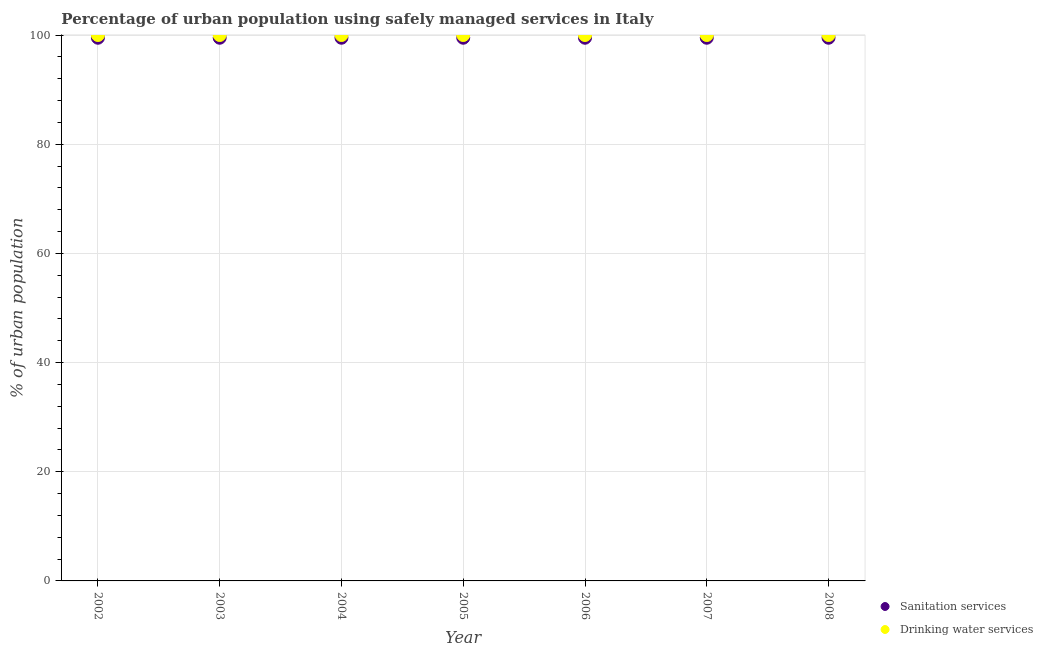How many different coloured dotlines are there?
Ensure brevity in your answer.  2. Is the number of dotlines equal to the number of legend labels?
Give a very brief answer. Yes. What is the percentage of urban population who used sanitation services in 2006?
Offer a terse response. 99.5. Across all years, what is the maximum percentage of urban population who used sanitation services?
Make the answer very short. 99.5. Across all years, what is the minimum percentage of urban population who used drinking water services?
Offer a very short reply. 100. In which year was the percentage of urban population who used sanitation services maximum?
Your answer should be compact. 2002. In which year was the percentage of urban population who used drinking water services minimum?
Provide a short and direct response. 2002. What is the total percentage of urban population who used sanitation services in the graph?
Provide a short and direct response. 696.5. What is the difference between the percentage of urban population who used sanitation services in 2002 and the percentage of urban population who used drinking water services in 2004?
Make the answer very short. -0.5. What is the average percentage of urban population who used drinking water services per year?
Your response must be concise. 100. In how many years, is the percentage of urban population who used drinking water services greater than 12 %?
Make the answer very short. 7. Is the percentage of urban population who used drinking water services in 2005 less than that in 2007?
Your response must be concise. No. Is the difference between the percentage of urban population who used sanitation services in 2005 and 2007 greater than the difference between the percentage of urban population who used drinking water services in 2005 and 2007?
Keep it short and to the point. No. What is the difference between the highest and the second highest percentage of urban population who used sanitation services?
Keep it short and to the point. 0. What is the difference between the highest and the lowest percentage of urban population who used drinking water services?
Offer a very short reply. 0. Is the sum of the percentage of urban population who used sanitation services in 2003 and 2004 greater than the maximum percentage of urban population who used drinking water services across all years?
Give a very brief answer. Yes. Does the percentage of urban population who used drinking water services monotonically increase over the years?
Keep it short and to the point. No. Is the percentage of urban population who used drinking water services strictly less than the percentage of urban population who used sanitation services over the years?
Offer a very short reply. No. How many years are there in the graph?
Ensure brevity in your answer.  7. Does the graph contain any zero values?
Your response must be concise. No. Does the graph contain grids?
Offer a very short reply. Yes. Where does the legend appear in the graph?
Make the answer very short. Bottom right. What is the title of the graph?
Ensure brevity in your answer.  Percentage of urban population using safely managed services in Italy. What is the label or title of the X-axis?
Make the answer very short. Year. What is the label or title of the Y-axis?
Your answer should be compact. % of urban population. What is the % of urban population in Sanitation services in 2002?
Make the answer very short. 99.5. What is the % of urban population in Sanitation services in 2003?
Provide a short and direct response. 99.5. What is the % of urban population in Drinking water services in 2003?
Offer a terse response. 100. What is the % of urban population of Sanitation services in 2004?
Provide a succinct answer. 99.5. What is the % of urban population in Drinking water services in 2004?
Ensure brevity in your answer.  100. What is the % of urban population in Sanitation services in 2005?
Provide a succinct answer. 99.5. What is the % of urban population of Sanitation services in 2006?
Make the answer very short. 99.5. What is the % of urban population of Drinking water services in 2006?
Ensure brevity in your answer.  100. What is the % of urban population of Sanitation services in 2007?
Offer a terse response. 99.5. What is the % of urban population in Sanitation services in 2008?
Provide a succinct answer. 99.5. What is the % of urban population of Drinking water services in 2008?
Offer a very short reply. 100. Across all years, what is the maximum % of urban population of Sanitation services?
Your response must be concise. 99.5. Across all years, what is the maximum % of urban population of Drinking water services?
Your response must be concise. 100. Across all years, what is the minimum % of urban population in Sanitation services?
Offer a terse response. 99.5. What is the total % of urban population in Sanitation services in the graph?
Provide a succinct answer. 696.5. What is the total % of urban population in Drinking water services in the graph?
Provide a succinct answer. 700. What is the difference between the % of urban population in Sanitation services in 2002 and that in 2003?
Provide a short and direct response. 0. What is the difference between the % of urban population in Sanitation services in 2002 and that in 2005?
Provide a succinct answer. 0. What is the difference between the % of urban population in Sanitation services in 2002 and that in 2006?
Provide a succinct answer. 0. What is the difference between the % of urban population of Drinking water services in 2002 and that in 2007?
Offer a terse response. 0. What is the difference between the % of urban population of Sanitation services in 2002 and that in 2008?
Keep it short and to the point. 0. What is the difference between the % of urban population in Drinking water services in 2002 and that in 2008?
Keep it short and to the point. 0. What is the difference between the % of urban population in Sanitation services in 2003 and that in 2004?
Your answer should be very brief. 0. What is the difference between the % of urban population of Sanitation services in 2003 and that in 2005?
Your answer should be compact. 0. What is the difference between the % of urban population in Drinking water services in 2003 and that in 2005?
Offer a very short reply. 0. What is the difference between the % of urban population in Sanitation services in 2003 and that in 2006?
Ensure brevity in your answer.  0. What is the difference between the % of urban population in Sanitation services in 2004 and that in 2005?
Make the answer very short. 0. What is the difference between the % of urban population in Drinking water services in 2004 and that in 2005?
Offer a very short reply. 0. What is the difference between the % of urban population in Drinking water services in 2004 and that in 2006?
Offer a terse response. 0. What is the difference between the % of urban population of Sanitation services in 2004 and that in 2007?
Ensure brevity in your answer.  0. What is the difference between the % of urban population in Drinking water services in 2004 and that in 2007?
Provide a succinct answer. 0. What is the difference between the % of urban population of Drinking water services in 2005 and that in 2006?
Your answer should be compact. 0. What is the difference between the % of urban population in Sanitation services in 2005 and that in 2007?
Your answer should be compact. 0. What is the difference between the % of urban population of Drinking water services in 2006 and that in 2007?
Keep it short and to the point. 0. What is the difference between the % of urban population in Sanitation services in 2007 and that in 2008?
Your response must be concise. 0. What is the difference between the % of urban population in Sanitation services in 2002 and the % of urban population in Drinking water services in 2003?
Make the answer very short. -0.5. What is the difference between the % of urban population of Sanitation services in 2002 and the % of urban population of Drinking water services in 2007?
Your answer should be very brief. -0.5. What is the difference between the % of urban population of Sanitation services in 2002 and the % of urban population of Drinking water services in 2008?
Make the answer very short. -0.5. What is the difference between the % of urban population of Sanitation services in 2003 and the % of urban population of Drinking water services in 2005?
Your answer should be compact. -0.5. What is the difference between the % of urban population in Sanitation services in 2003 and the % of urban population in Drinking water services in 2008?
Make the answer very short. -0.5. What is the difference between the % of urban population in Sanitation services in 2004 and the % of urban population in Drinking water services in 2005?
Make the answer very short. -0.5. What is the difference between the % of urban population in Sanitation services in 2004 and the % of urban population in Drinking water services in 2006?
Ensure brevity in your answer.  -0.5. What is the difference between the % of urban population of Sanitation services in 2004 and the % of urban population of Drinking water services in 2007?
Give a very brief answer. -0.5. What is the difference between the % of urban population of Sanitation services in 2004 and the % of urban population of Drinking water services in 2008?
Keep it short and to the point. -0.5. What is the difference between the % of urban population of Sanitation services in 2005 and the % of urban population of Drinking water services in 2006?
Your response must be concise. -0.5. What is the difference between the % of urban population of Sanitation services in 2005 and the % of urban population of Drinking water services in 2007?
Offer a terse response. -0.5. What is the difference between the % of urban population of Sanitation services in 2005 and the % of urban population of Drinking water services in 2008?
Make the answer very short. -0.5. What is the difference between the % of urban population in Sanitation services in 2006 and the % of urban population in Drinking water services in 2008?
Offer a very short reply. -0.5. What is the average % of urban population of Sanitation services per year?
Provide a short and direct response. 99.5. In the year 2002, what is the difference between the % of urban population in Sanitation services and % of urban population in Drinking water services?
Provide a short and direct response. -0.5. In the year 2005, what is the difference between the % of urban population in Sanitation services and % of urban population in Drinking water services?
Provide a short and direct response. -0.5. In the year 2007, what is the difference between the % of urban population of Sanitation services and % of urban population of Drinking water services?
Offer a terse response. -0.5. In the year 2008, what is the difference between the % of urban population in Sanitation services and % of urban population in Drinking water services?
Offer a terse response. -0.5. What is the ratio of the % of urban population of Drinking water services in 2002 to that in 2003?
Make the answer very short. 1. What is the ratio of the % of urban population of Sanitation services in 2002 to that in 2004?
Make the answer very short. 1. What is the ratio of the % of urban population in Drinking water services in 2002 to that in 2004?
Ensure brevity in your answer.  1. What is the ratio of the % of urban population in Sanitation services in 2002 to that in 2005?
Make the answer very short. 1. What is the ratio of the % of urban population in Sanitation services in 2002 to that in 2006?
Ensure brevity in your answer.  1. What is the ratio of the % of urban population in Sanitation services in 2002 to that in 2007?
Offer a very short reply. 1. What is the ratio of the % of urban population of Sanitation services in 2003 to that in 2004?
Your response must be concise. 1. What is the ratio of the % of urban population in Drinking water services in 2003 to that in 2004?
Your answer should be compact. 1. What is the ratio of the % of urban population in Drinking water services in 2003 to that in 2005?
Provide a short and direct response. 1. What is the ratio of the % of urban population of Drinking water services in 2003 to that in 2007?
Your answer should be compact. 1. What is the ratio of the % of urban population of Sanitation services in 2003 to that in 2008?
Ensure brevity in your answer.  1. What is the ratio of the % of urban population of Sanitation services in 2004 to that in 2005?
Provide a succinct answer. 1. What is the ratio of the % of urban population of Drinking water services in 2004 to that in 2005?
Your answer should be compact. 1. What is the ratio of the % of urban population in Sanitation services in 2004 to that in 2007?
Offer a terse response. 1. What is the ratio of the % of urban population of Drinking water services in 2004 to that in 2007?
Offer a terse response. 1. What is the ratio of the % of urban population of Drinking water services in 2004 to that in 2008?
Offer a terse response. 1. What is the ratio of the % of urban population in Sanitation services in 2005 to that in 2007?
Your response must be concise. 1. What is the ratio of the % of urban population of Sanitation services in 2006 to that in 2007?
Offer a very short reply. 1. What is the ratio of the % of urban population of Drinking water services in 2006 to that in 2008?
Provide a short and direct response. 1. 